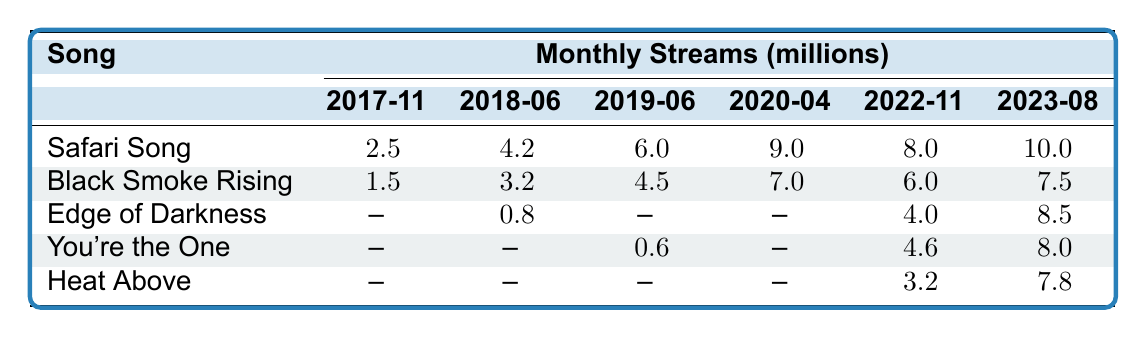What were the monthly streams for "Safari Song" in June 2018? According to the table, the monthly streams for "Safari Song" in June 2018 are 4.2 million.
Answer: 4.2 million Which song had the highest monthly streams in August 2023? The table indicates that "Safari Song" had the highest monthly streams in August 2023, reaching 10.0 million.
Answer: "Safari Song" In which month did "Black Smoke Rising" reach 7 million streams? Referring to the table, "Black Smoke Rising" reached 7 million streams in April 2020.
Answer: April 2020 What is the difference in monthly streams of "Edge of Darkness" between November 2022 and August 2023? The monthly streams for "Edge of Darkness" in November 2022 were 4.0 million, and in August 2023 they were 8.5 million. The difference is 8.5 - 4.0 = 4.5 million.
Answer: 4.5 million Did "You're the One" have any streams recorded in June 2017? Looking at the data, "You're the One" has no recorded streams in June 2017; it only has data starting from March 2019.
Answer: No What is the average number of monthly streams for "Heat Above" from its available data in the table? The monthly streams for "Heat Above" are listed for July 2021 (0.9), December 2021 (1.5), February 2022 (2.0), June 2022 (2.7), October 2022 (3.2), January 2023 (4.0), June 2023 (5.5), and August 2023 (7.8). Adding these values gives 1.5 + 2.0 + 2.7 + 3.2 + 4.0 + 5.5 + 7.8 = 27.7. Dividing by the number of months (8) gives an average of 3.46 million.
Answer: 3.46 million If you compare the streams of "Safari Song" and "Black Smoke Rising" in December 2017, which one had more? "Safari Song" had 2.5 million streams, while "Black Smoke Rising" had 1.7 million streams in December 2017. Therefore, "Safari Song" had more.
Answer: "Safari Song" What is the total number of monthly streams for "Black Smoke Rising" available in the table? To find the total streams, add the monthly streams for each available month: 1.5 + 1.7 + 2.0 + 2.5 + 2.6 + 2.8 + 2.9 + 3.2 + 3.4 + 3.5 + 3.6 + 3.75 + 4.0 + 4.5 + 7.0 + 5.0 + 6.0 + 7.5 = 61.7 million.
Answer: 61.7 million In which month did "Heat Above" first reach over 2 million streams? The first instance where "Heat Above" reached over 2 million streams was in June 2022, where it had 2.7 million streams.
Answer: June 2022 How many songs had data recorded for August 2023? The table shows that three songs ("Safari Song," "Black Smoke Rising," and "Edge of Darkness") had data recorded for August 2023.
Answer: Three songs Compare the maximum monthly streams of "You're the One" to "Edge of Darkness." Which song had more maximum streams? "You're the One" reached a maximum of 8.0 million in August 2023, while "Edge of Darkness" reached a maximum of 8.5 million in August 2023 as well. Therefore, "Edge of Darkness" had more.
Answer: "Edge of Darkness" 